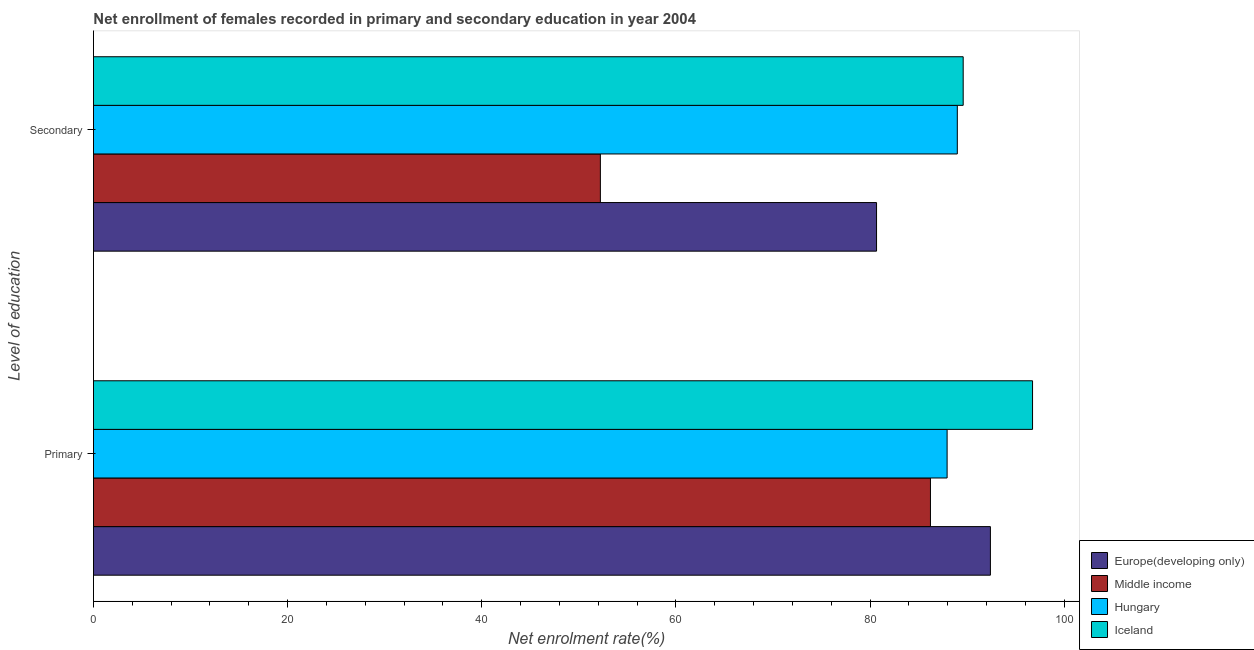How many groups of bars are there?
Your response must be concise. 2. Are the number of bars per tick equal to the number of legend labels?
Provide a short and direct response. Yes. Are the number of bars on each tick of the Y-axis equal?
Ensure brevity in your answer.  Yes. How many bars are there on the 2nd tick from the bottom?
Provide a succinct answer. 4. What is the label of the 2nd group of bars from the top?
Give a very brief answer. Primary. What is the enrollment rate in secondary education in Hungary?
Provide a succinct answer. 88.98. Across all countries, what is the maximum enrollment rate in primary education?
Your answer should be very brief. 96.73. Across all countries, what is the minimum enrollment rate in secondary education?
Your answer should be compact. 52.21. What is the total enrollment rate in secondary education in the graph?
Offer a terse response. 311.44. What is the difference between the enrollment rate in secondary education in Middle income and that in Iceland?
Your answer should be very brief. -37.37. What is the difference between the enrollment rate in primary education in Hungary and the enrollment rate in secondary education in Europe(developing only)?
Make the answer very short. 7.27. What is the average enrollment rate in primary education per country?
Keep it short and to the point. 90.81. What is the difference between the enrollment rate in primary education and enrollment rate in secondary education in Europe(developing only)?
Your answer should be very brief. 11.73. What is the ratio of the enrollment rate in primary education in Middle income to that in Iceland?
Your answer should be compact. 0.89. How many bars are there?
Your answer should be compact. 8. How many countries are there in the graph?
Provide a succinct answer. 4. What is the difference between two consecutive major ticks on the X-axis?
Offer a very short reply. 20. Are the values on the major ticks of X-axis written in scientific E-notation?
Ensure brevity in your answer.  No. Does the graph contain any zero values?
Give a very brief answer. No. Does the graph contain grids?
Your response must be concise. No. Where does the legend appear in the graph?
Provide a succinct answer. Bottom right. How many legend labels are there?
Provide a succinct answer. 4. How are the legend labels stacked?
Make the answer very short. Vertical. What is the title of the graph?
Give a very brief answer. Net enrollment of females recorded in primary and secondary education in year 2004. What is the label or title of the X-axis?
Keep it short and to the point. Net enrolment rate(%). What is the label or title of the Y-axis?
Provide a short and direct response. Level of education. What is the Net enrolment rate(%) of Europe(developing only) in Primary?
Provide a short and direct response. 92.39. What is the Net enrolment rate(%) in Middle income in Primary?
Your response must be concise. 86.21. What is the Net enrolment rate(%) of Hungary in Primary?
Your answer should be compact. 87.93. What is the Net enrolment rate(%) of Iceland in Primary?
Your answer should be very brief. 96.73. What is the Net enrolment rate(%) in Europe(developing only) in Secondary?
Offer a very short reply. 80.66. What is the Net enrolment rate(%) of Middle income in Secondary?
Ensure brevity in your answer.  52.21. What is the Net enrolment rate(%) in Hungary in Secondary?
Ensure brevity in your answer.  88.98. What is the Net enrolment rate(%) in Iceland in Secondary?
Your response must be concise. 89.58. Across all Level of education, what is the maximum Net enrolment rate(%) in Europe(developing only)?
Provide a succinct answer. 92.39. Across all Level of education, what is the maximum Net enrolment rate(%) of Middle income?
Your answer should be very brief. 86.21. Across all Level of education, what is the maximum Net enrolment rate(%) in Hungary?
Give a very brief answer. 88.98. Across all Level of education, what is the maximum Net enrolment rate(%) of Iceland?
Offer a very short reply. 96.73. Across all Level of education, what is the minimum Net enrolment rate(%) of Europe(developing only)?
Your answer should be compact. 80.66. Across all Level of education, what is the minimum Net enrolment rate(%) in Middle income?
Offer a terse response. 52.21. Across all Level of education, what is the minimum Net enrolment rate(%) in Hungary?
Offer a terse response. 87.93. Across all Level of education, what is the minimum Net enrolment rate(%) of Iceland?
Provide a short and direct response. 89.58. What is the total Net enrolment rate(%) of Europe(developing only) in the graph?
Make the answer very short. 173.05. What is the total Net enrolment rate(%) of Middle income in the graph?
Your answer should be very brief. 138.43. What is the total Net enrolment rate(%) in Hungary in the graph?
Give a very brief answer. 176.91. What is the total Net enrolment rate(%) in Iceland in the graph?
Your answer should be compact. 186.31. What is the difference between the Net enrolment rate(%) in Europe(developing only) in Primary and that in Secondary?
Offer a terse response. 11.73. What is the difference between the Net enrolment rate(%) in Middle income in Primary and that in Secondary?
Offer a terse response. 34. What is the difference between the Net enrolment rate(%) of Hungary in Primary and that in Secondary?
Your answer should be compact. -1.05. What is the difference between the Net enrolment rate(%) in Iceland in Primary and that in Secondary?
Offer a terse response. 7.15. What is the difference between the Net enrolment rate(%) of Europe(developing only) in Primary and the Net enrolment rate(%) of Middle income in Secondary?
Your response must be concise. 40.18. What is the difference between the Net enrolment rate(%) of Europe(developing only) in Primary and the Net enrolment rate(%) of Hungary in Secondary?
Provide a succinct answer. 3.41. What is the difference between the Net enrolment rate(%) in Europe(developing only) in Primary and the Net enrolment rate(%) in Iceland in Secondary?
Your response must be concise. 2.8. What is the difference between the Net enrolment rate(%) of Middle income in Primary and the Net enrolment rate(%) of Hungary in Secondary?
Provide a succinct answer. -2.77. What is the difference between the Net enrolment rate(%) in Middle income in Primary and the Net enrolment rate(%) in Iceland in Secondary?
Your response must be concise. -3.37. What is the difference between the Net enrolment rate(%) in Hungary in Primary and the Net enrolment rate(%) in Iceland in Secondary?
Keep it short and to the point. -1.66. What is the average Net enrolment rate(%) of Europe(developing only) per Level of education?
Provide a succinct answer. 86.52. What is the average Net enrolment rate(%) of Middle income per Level of education?
Offer a very short reply. 69.21. What is the average Net enrolment rate(%) of Hungary per Level of education?
Keep it short and to the point. 88.45. What is the average Net enrolment rate(%) of Iceland per Level of education?
Give a very brief answer. 93.16. What is the difference between the Net enrolment rate(%) in Europe(developing only) and Net enrolment rate(%) in Middle income in Primary?
Your answer should be very brief. 6.18. What is the difference between the Net enrolment rate(%) in Europe(developing only) and Net enrolment rate(%) in Hungary in Primary?
Your answer should be very brief. 4.46. What is the difference between the Net enrolment rate(%) of Europe(developing only) and Net enrolment rate(%) of Iceland in Primary?
Provide a succinct answer. -4.34. What is the difference between the Net enrolment rate(%) in Middle income and Net enrolment rate(%) in Hungary in Primary?
Your answer should be compact. -1.72. What is the difference between the Net enrolment rate(%) of Middle income and Net enrolment rate(%) of Iceland in Primary?
Offer a terse response. -10.52. What is the difference between the Net enrolment rate(%) of Hungary and Net enrolment rate(%) of Iceland in Primary?
Your answer should be compact. -8.8. What is the difference between the Net enrolment rate(%) in Europe(developing only) and Net enrolment rate(%) in Middle income in Secondary?
Offer a terse response. 28.45. What is the difference between the Net enrolment rate(%) in Europe(developing only) and Net enrolment rate(%) in Hungary in Secondary?
Provide a succinct answer. -8.32. What is the difference between the Net enrolment rate(%) of Europe(developing only) and Net enrolment rate(%) of Iceland in Secondary?
Your answer should be compact. -8.92. What is the difference between the Net enrolment rate(%) of Middle income and Net enrolment rate(%) of Hungary in Secondary?
Your answer should be very brief. -36.77. What is the difference between the Net enrolment rate(%) of Middle income and Net enrolment rate(%) of Iceland in Secondary?
Give a very brief answer. -37.37. What is the difference between the Net enrolment rate(%) of Hungary and Net enrolment rate(%) of Iceland in Secondary?
Your answer should be very brief. -0.61. What is the ratio of the Net enrolment rate(%) in Europe(developing only) in Primary to that in Secondary?
Offer a terse response. 1.15. What is the ratio of the Net enrolment rate(%) in Middle income in Primary to that in Secondary?
Offer a very short reply. 1.65. What is the ratio of the Net enrolment rate(%) in Hungary in Primary to that in Secondary?
Your answer should be very brief. 0.99. What is the ratio of the Net enrolment rate(%) of Iceland in Primary to that in Secondary?
Provide a short and direct response. 1.08. What is the difference between the highest and the second highest Net enrolment rate(%) in Europe(developing only)?
Your answer should be very brief. 11.73. What is the difference between the highest and the second highest Net enrolment rate(%) in Middle income?
Ensure brevity in your answer.  34. What is the difference between the highest and the second highest Net enrolment rate(%) of Hungary?
Make the answer very short. 1.05. What is the difference between the highest and the second highest Net enrolment rate(%) in Iceland?
Your answer should be compact. 7.15. What is the difference between the highest and the lowest Net enrolment rate(%) of Europe(developing only)?
Provide a succinct answer. 11.73. What is the difference between the highest and the lowest Net enrolment rate(%) of Middle income?
Provide a short and direct response. 34. What is the difference between the highest and the lowest Net enrolment rate(%) of Hungary?
Give a very brief answer. 1.05. What is the difference between the highest and the lowest Net enrolment rate(%) in Iceland?
Provide a short and direct response. 7.15. 